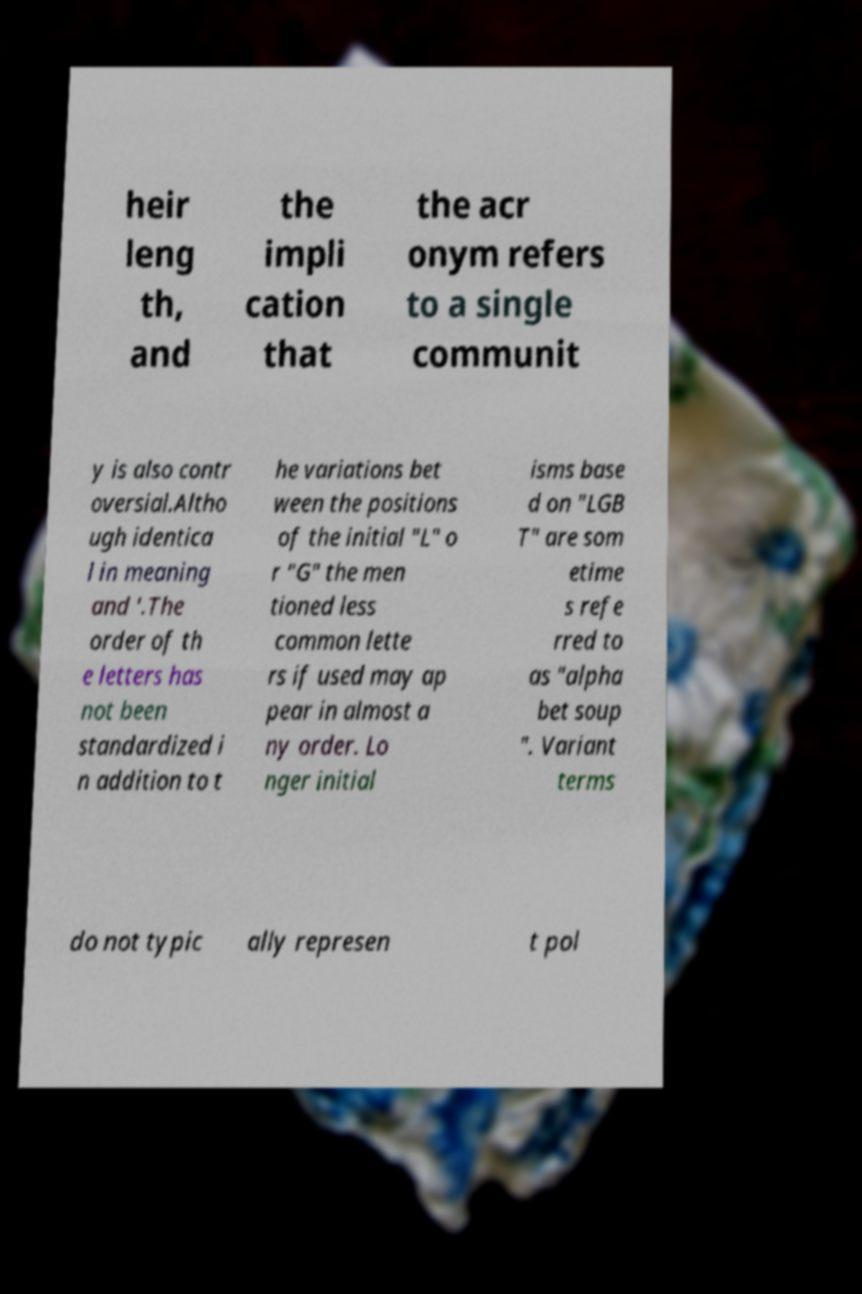Can you accurately transcribe the text from the provided image for me? heir leng th, and the impli cation that the acr onym refers to a single communit y is also contr oversial.Altho ugh identica l in meaning and '.The order of th e letters has not been standardized i n addition to t he variations bet ween the positions of the initial "L" o r "G" the men tioned less common lette rs if used may ap pear in almost a ny order. Lo nger initial isms base d on "LGB T" are som etime s refe rred to as "alpha bet soup ". Variant terms do not typic ally represen t pol 